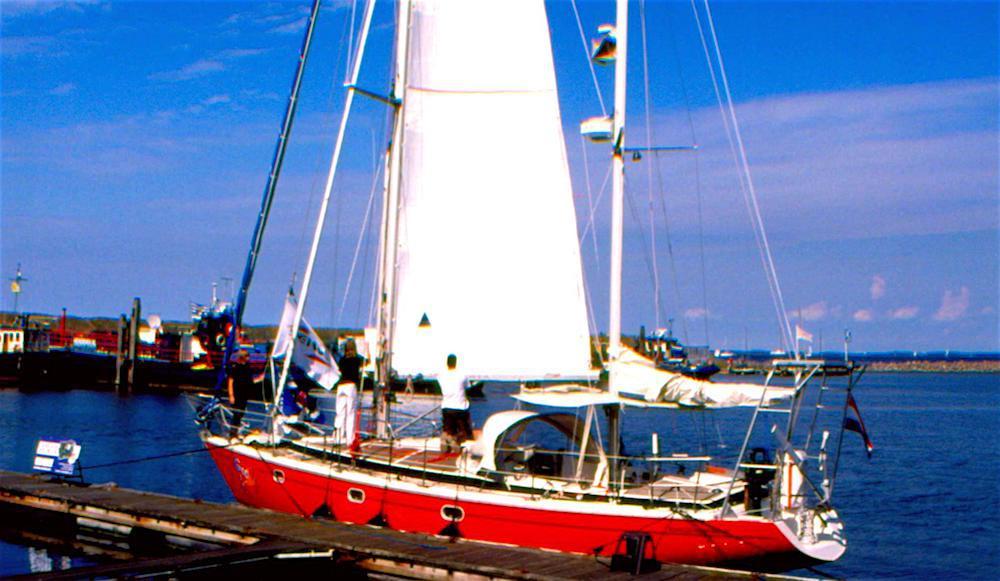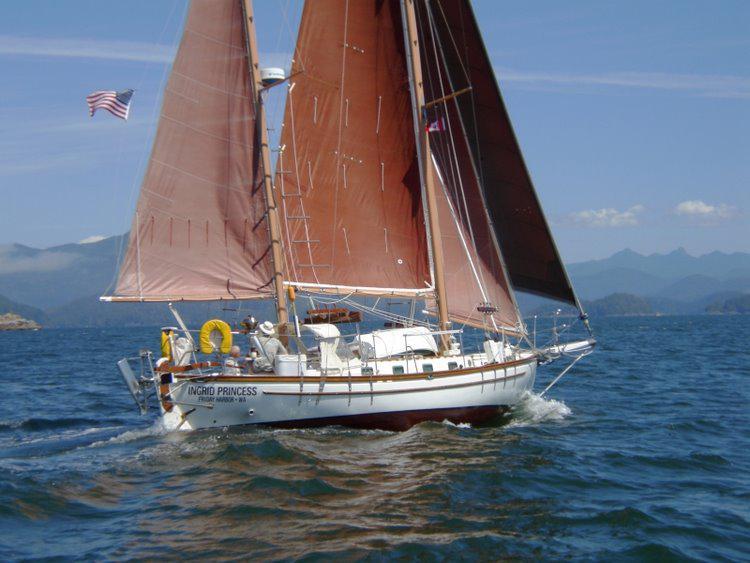The first image is the image on the left, the second image is the image on the right. Examine the images to the left and right. Is the description "There’s a single sailboat with at least three brick colored sail deployed to help the boat move." accurate? Answer yes or no. Yes. The first image is the image on the left, the second image is the image on the right. For the images displayed, is the sentence "Sailboat with three white sails has no more than two clouds in the sky." factually correct? Answer yes or no. No. 